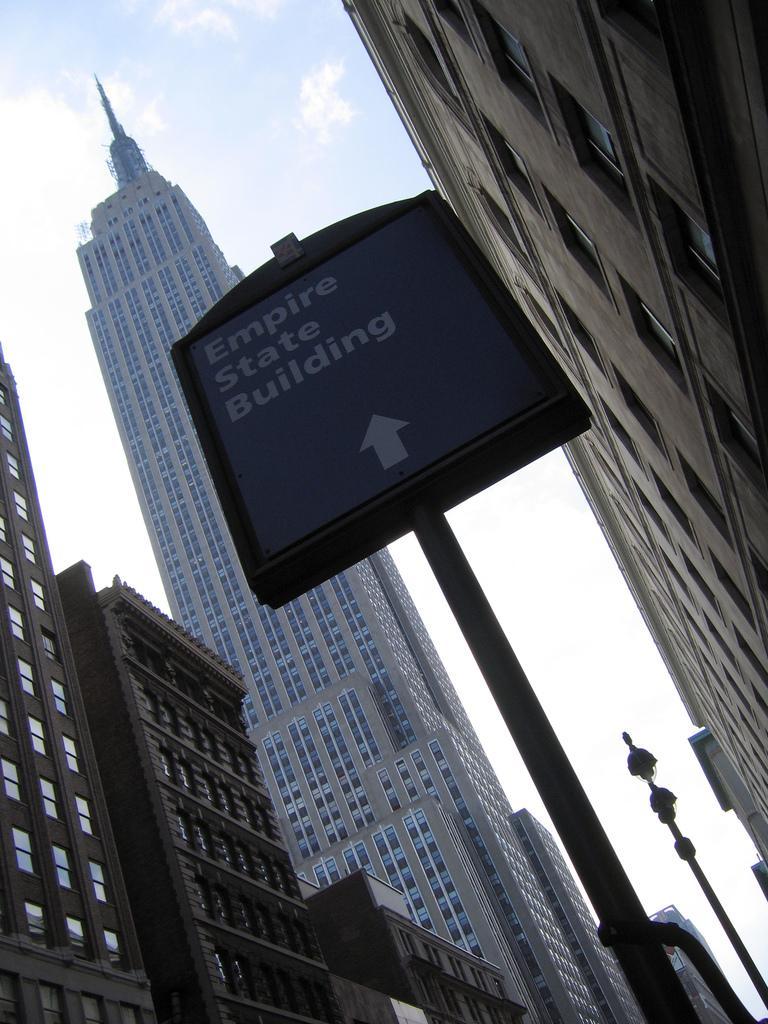Describe this image in one or two sentences. In this image I can see few buildings, number of windows, few poles, clouds, the sky, a board and on this board I can see something is written. 